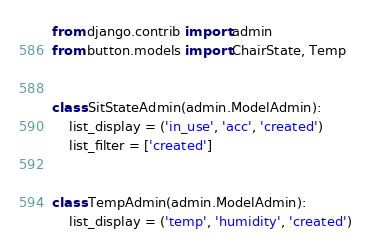Convert code to text. <code><loc_0><loc_0><loc_500><loc_500><_Python_>from django.contrib import admin
from button.models import ChairState, Temp


class SitStateAdmin(admin.ModelAdmin):
    list_display = ('in_use', 'acc', 'created')
    list_filter = ['created']


class TempAdmin(admin.ModelAdmin):
    list_display = ('temp', 'humidity', 'created')</code> 